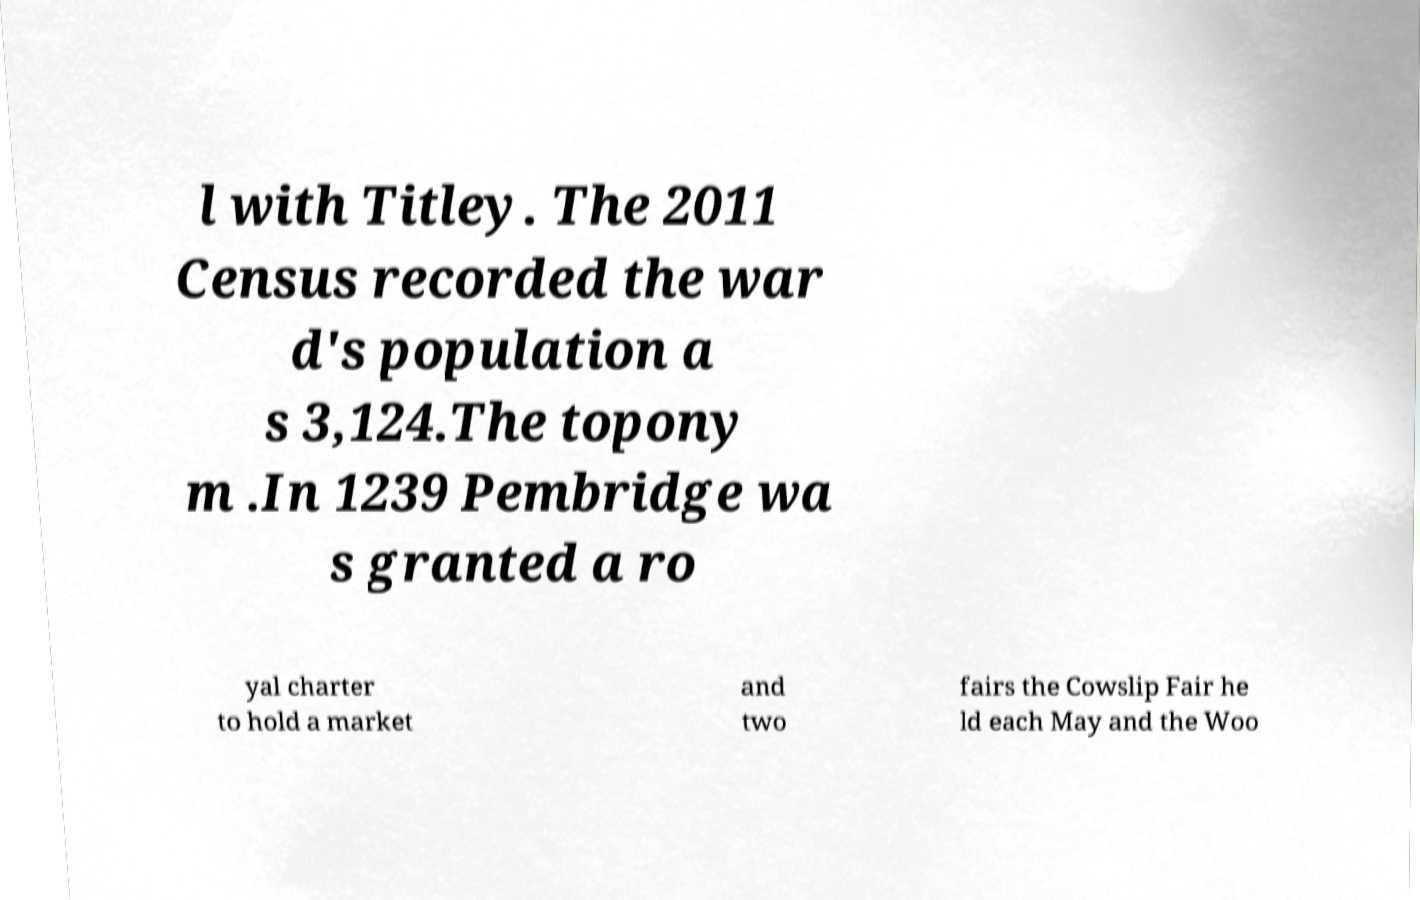Please read and relay the text visible in this image. What does it say? l with Titley. The 2011 Census recorded the war d's population a s 3,124.The topony m .In 1239 Pembridge wa s granted a ro yal charter to hold a market and two fairs the Cowslip Fair he ld each May and the Woo 